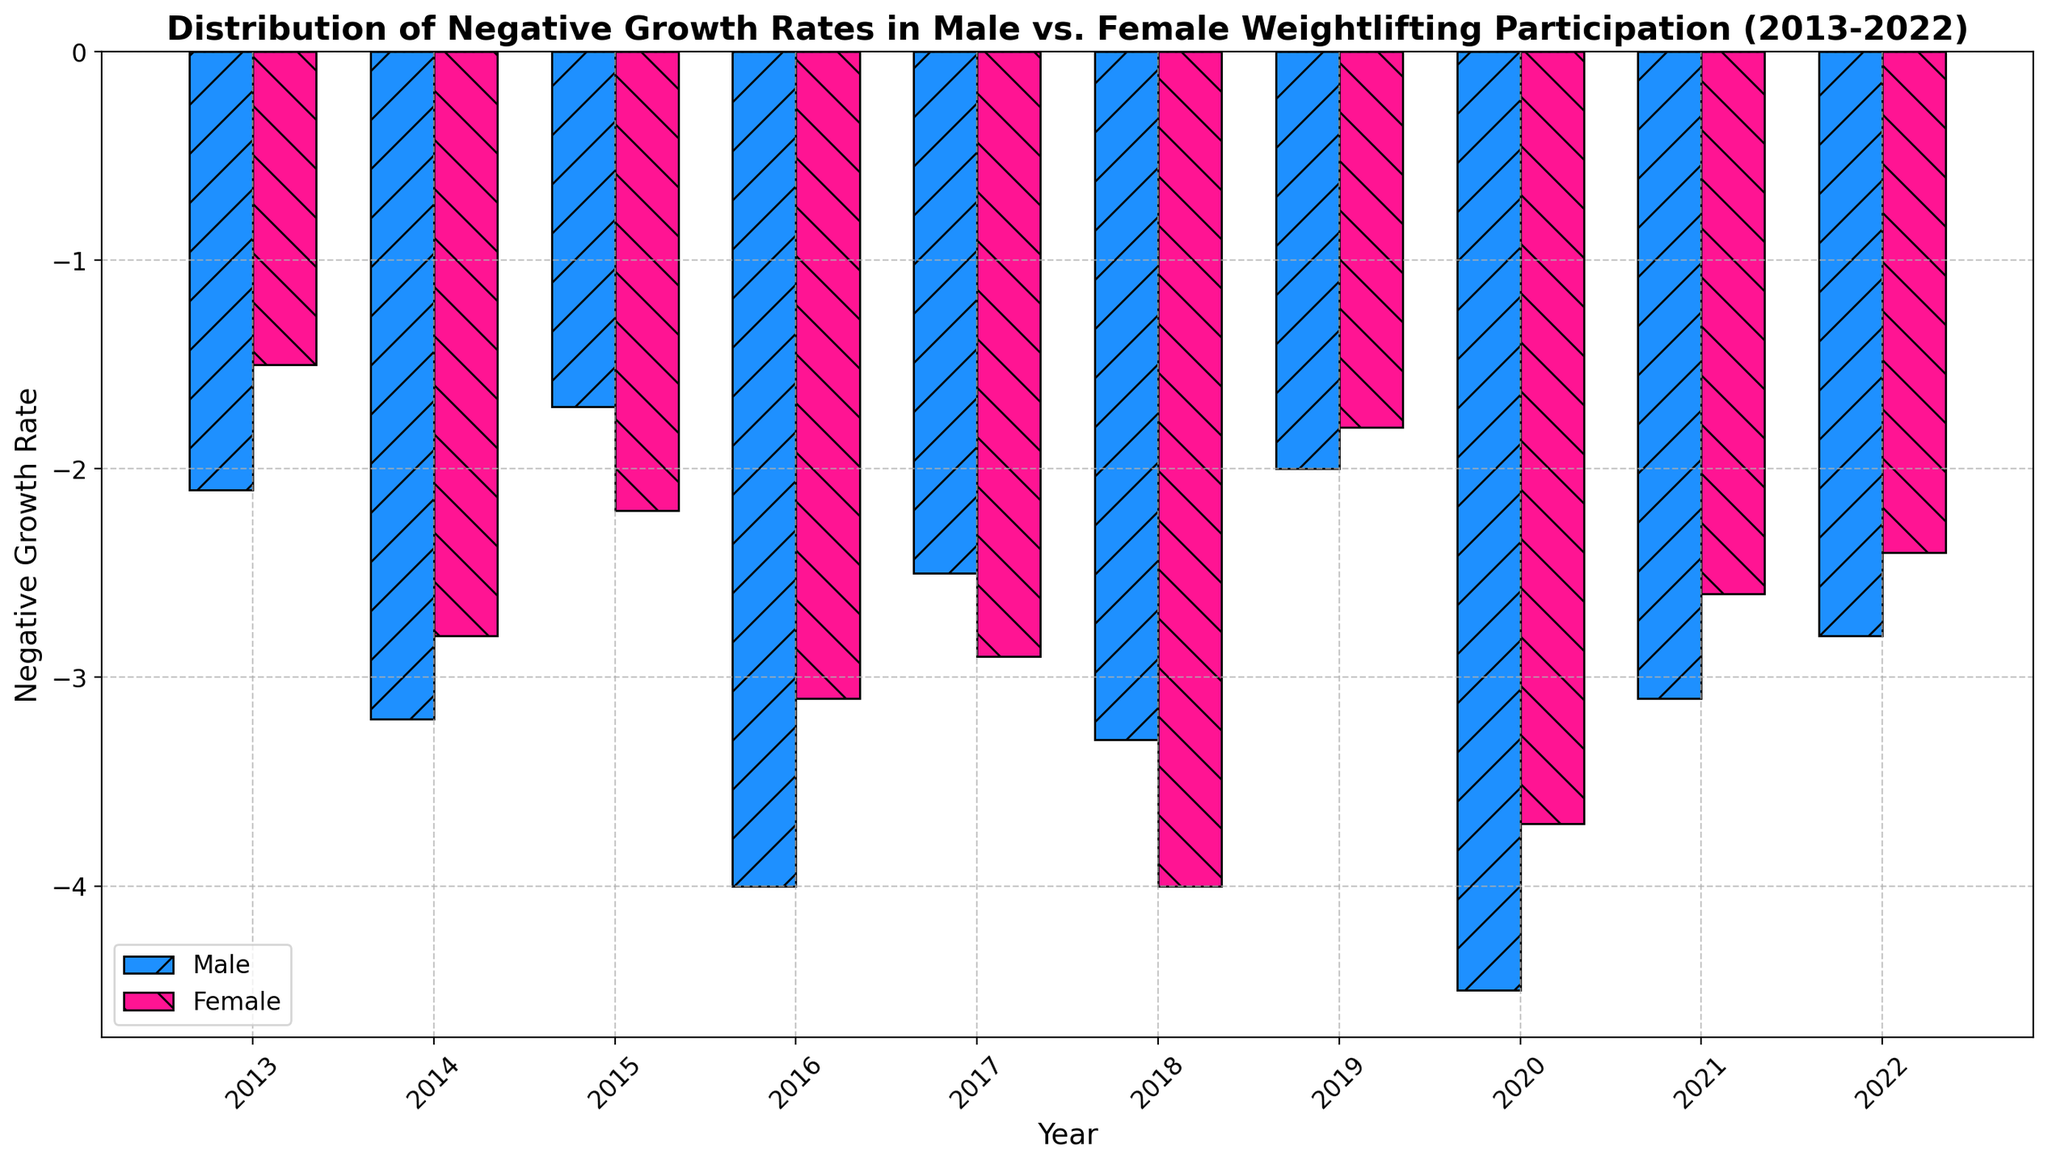Which year had the highest negative growth rate for male weightlifting participation? The highest bar among the bars representing male participation indicates the year with the highest negative growth rate.
Answer: 2020 Comparing the years 2016 and 2018, which had a larger negative growth rate for female weightlifting participation? Compare the heights of the bars for female participation in 2016 and 2018. The taller bar represents the larger negative growth rate.
Answer: 2018 In which years did both male and female weightlifting participation show the same trend, either increasing or decreasing compared to the previous year? Analyze each year's growth rate for both male and female, checking if both either increased or decreased when compared to the previous year's growth rate.
Answer: 2014, 2016, 2017, 2020 What's the average negative growth rate for female weightlifting participation over the past decade? Sum the negative growth rates for female weightlifting participation and divide by the number of years (10). Sum = -1.5 + -2.8 + -2.2 + -3.1 + -2.9 + -4.0 + -1.8 + -3.7 + -2.6 + -2.4 = -27.
Answer: -2.70 What is the total negative growth rate for male weightlifting participation from 2013 to 2022? Sum the negative growth rates for male weightlifting participation over the given years. Sum = -2.1 + -3.2 + -1.7 + -4.0 + -2.5 + -3.3 + -2.0 + -4.5 + -3.1 + -2.8 = -29.2
Answer: -29.2 Which year exhibited the smallest negative growth rate for female weightlifting participation? Identify the shortest bar among the bars representing female participation, indicating the smallest negative growth rate.
Answer: 2019 During which year was the negative growth rate for female weightlifting participation greater than that of male weightlifting participation? Compare the heights of the bars for each year; find the year where the female bar is taller (i.e., more negative) than the male bar.
Answer: 2018 